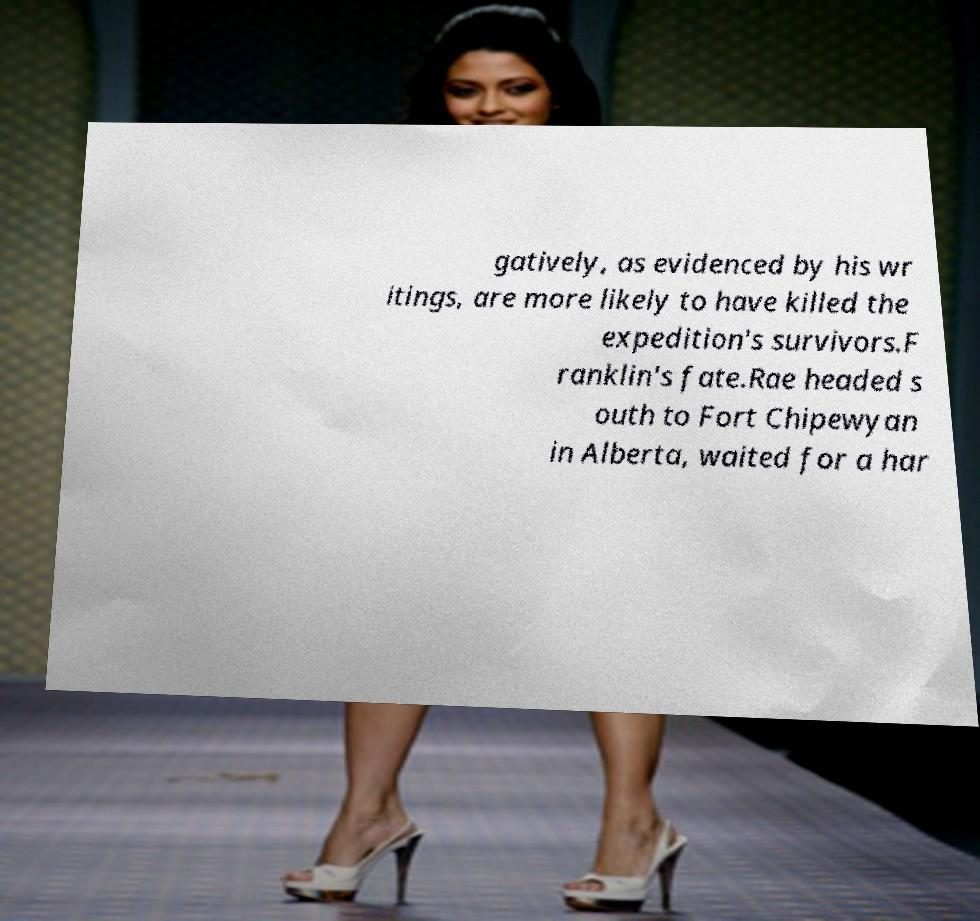For documentation purposes, I need the text within this image transcribed. Could you provide that? gatively, as evidenced by his wr itings, are more likely to have killed the expedition's survivors.F ranklin's fate.Rae headed s outh to Fort Chipewyan in Alberta, waited for a har 